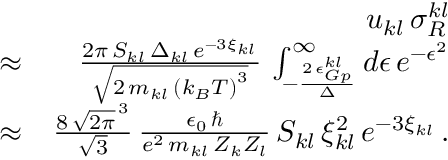Convert formula to latex. <formula><loc_0><loc_0><loc_500><loc_500>\begin{array} { r l r } & { u _ { k l } \, \sigma _ { R } ^ { k l } } \\ & { \approx } & { \frac { 2 \pi \, S _ { k l } \, \Delta _ { k l } \, e ^ { - 3 \xi _ { k l } } } { \sqrt { 2 \, m _ { k l } \, \left ( k _ { B } T \right ) ^ { 3 } } } \, \int _ { - \frac { 2 \, \epsilon _ { G p } ^ { k l } } { \Delta } } ^ { \infty } d \epsilon \, e ^ { - \epsilon ^ { 2 } } } \\ & { \approx } & { \frac { 8 \, \sqrt { 2 \pi } ^ { \, 3 } } { \sqrt { 3 } } \, \frac { \epsilon _ { 0 } \, } { e ^ { 2 } \, m _ { k l } \, Z _ { k } Z _ { l } } \, S _ { k l } \, \xi _ { k l } ^ { 2 } \, e ^ { - 3 \xi _ { k l } } \, . } \end{array}</formula> 